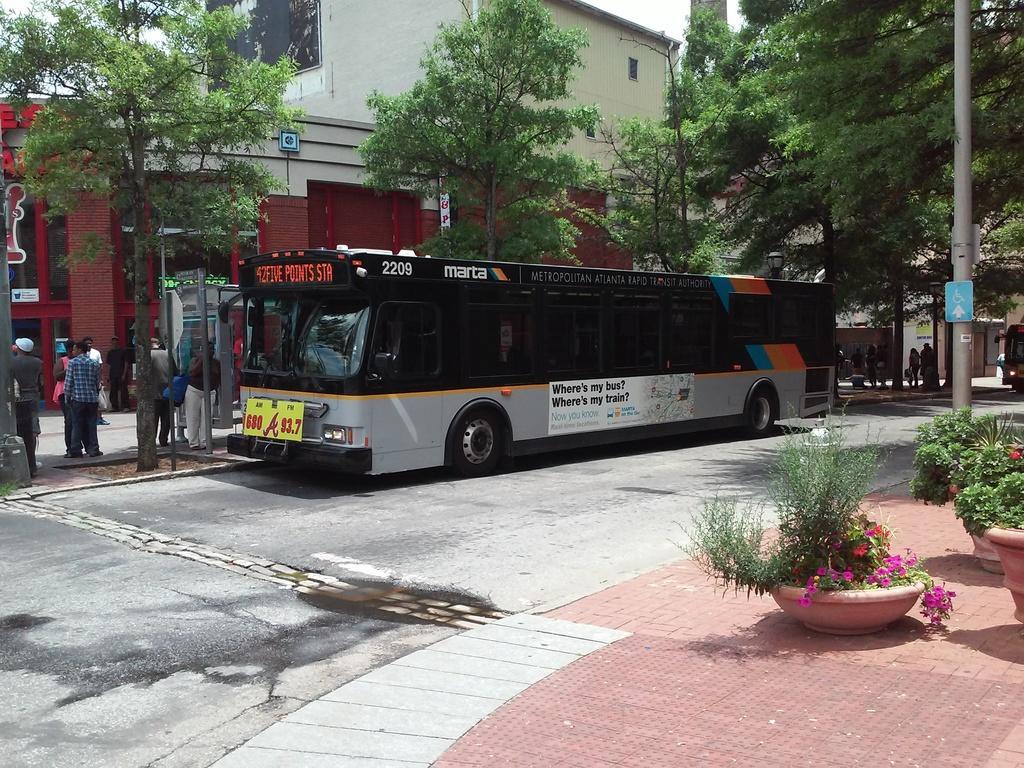In one or two sentences, can you explain what this image depicts? On the right side there is a sidewalk. On that there are pots with flowering plants. Also there is a pole with a board. And there is a road. On the road there is a bus with something written on that. Also there is a name board on the bus. Near to the bus there are people, trees and a building. In the background there are people and building. 